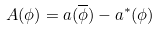<formula> <loc_0><loc_0><loc_500><loc_500>A ( \phi ) = a ( \overline { \phi } ) - a ^ { \ast } ( \phi )</formula> 